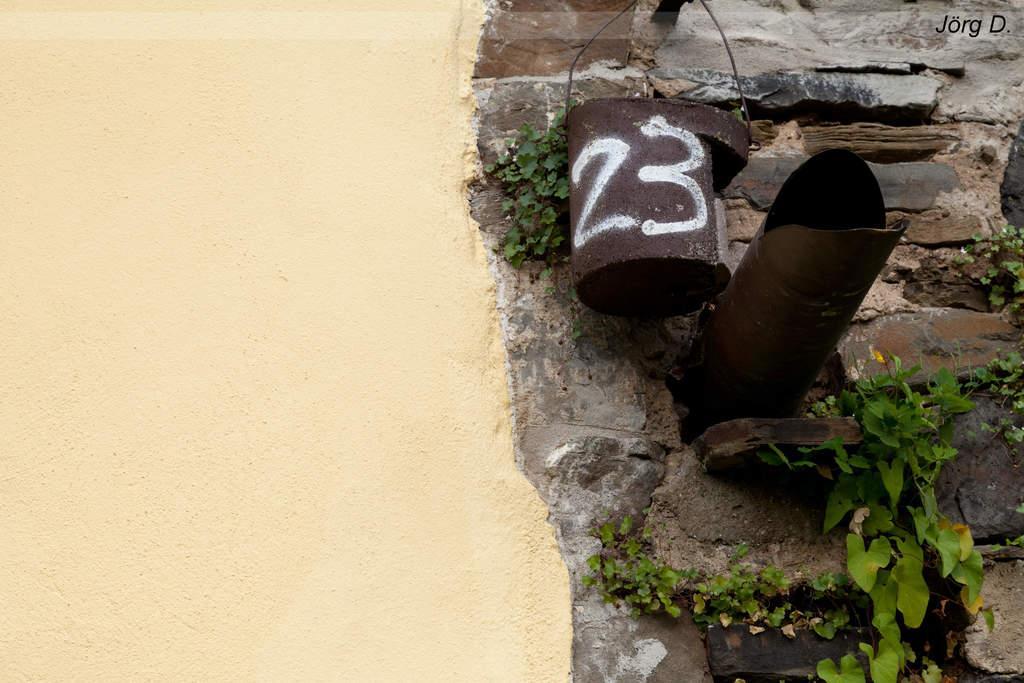How would you summarize this image in a sentence or two? In this image I can see the cream colored wall and the wall which is made up of rocks. I can see few plants which are green in color and few brown colored objects to the wall. 